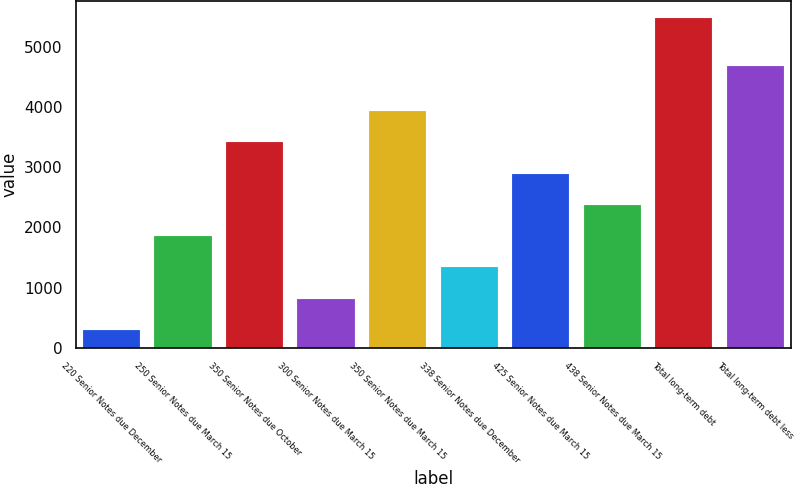Convert chart. <chart><loc_0><loc_0><loc_500><loc_500><bar_chart><fcel>220 Senior Notes due December<fcel>250 Senior Notes due March 15<fcel>350 Senior Notes due October<fcel>300 Senior Notes due March 15<fcel>350 Senior Notes due March 15<fcel>338 Senior Notes due December<fcel>425 Senior Notes due March 15<fcel>438 Senior Notes due March 15<fcel>Total long-term debt<fcel>Total long-term debt less<nl><fcel>299.5<fcel>1855.09<fcel>3410.68<fcel>818.03<fcel>3929.21<fcel>1336.56<fcel>2892.15<fcel>2373.62<fcel>5484.8<fcel>4686.3<nl></chart> 